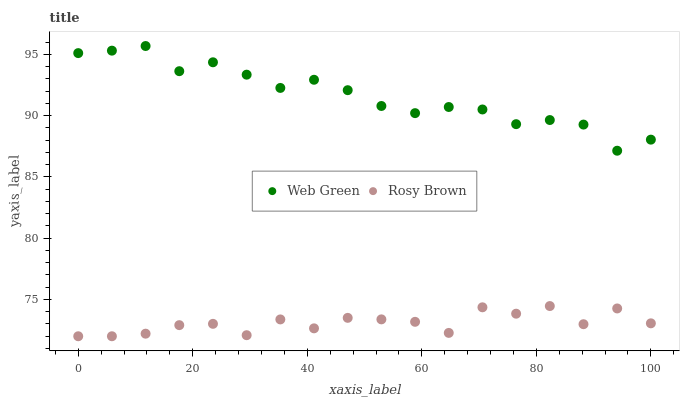Does Rosy Brown have the minimum area under the curve?
Answer yes or no. Yes. Does Web Green have the maximum area under the curve?
Answer yes or no. Yes. Does Web Green have the minimum area under the curve?
Answer yes or no. No. Is Web Green the smoothest?
Answer yes or no. Yes. Is Rosy Brown the roughest?
Answer yes or no. Yes. Is Web Green the roughest?
Answer yes or no. No. Does Rosy Brown have the lowest value?
Answer yes or no. Yes. Does Web Green have the lowest value?
Answer yes or no. No. Does Web Green have the highest value?
Answer yes or no. Yes. Is Rosy Brown less than Web Green?
Answer yes or no. Yes. Is Web Green greater than Rosy Brown?
Answer yes or no. Yes. Does Rosy Brown intersect Web Green?
Answer yes or no. No. 